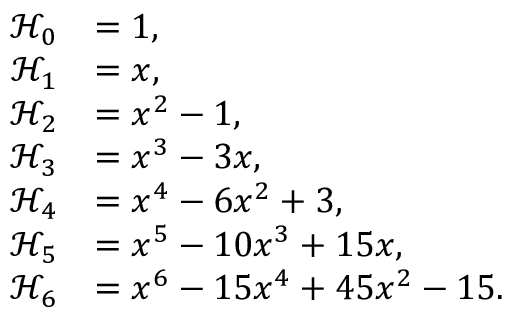<formula> <loc_0><loc_0><loc_500><loc_500>\begin{array} { r l } { \mathcal { H } _ { 0 } } & { = 1 , } \\ { \mathcal { H } _ { 1 } } & { = x , } \\ { \mathcal { H } _ { 2 } } & { = x ^ { 2 } - 1 , } \\ { \mathcal { H } _ { 3 } } & { = x ^ { 3 } - 3 x , } \\ { \mathcal { H } _ { 4 } } & { = x ^ { 4 } - 6 x ^ { 2 } + 3 , } \\ { \mathcal { H } _ { 5 } } & { = x ^ { 5 } - 1 0 x ^ { 3 } + 1 5 x , } \\ { \mathcal { H } _ { 6 } } & { = x ^ { 6 } - 1 5 x ^ { 4 } + 4 5 x ^ { 2 } - 1 5 . } \end{array}</formula> 